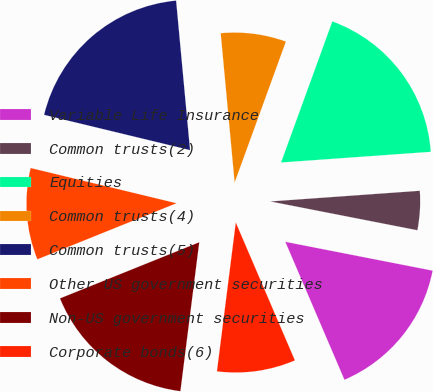Convert chart to OTSL. <chart><loc_0><loc_0><loc_500><loc_500><pie_chart><fcel>Variable Life Insurance<fcel>Common trusts(2)<fcel>Equities<fcel>Common trusts(4)<fcel>Common trusts(5)<fcel>Other US government securities<fcel>Non-US government securities<fcel>Corporate bonds(6)<nl><fcel>15.48%<fcel>4.21%<fcel>18.32%<fcel>7.03%<fcel>19.75%<fcel>9.87%<fcel>16.9%<fcel>8.45%<nl></chart> 